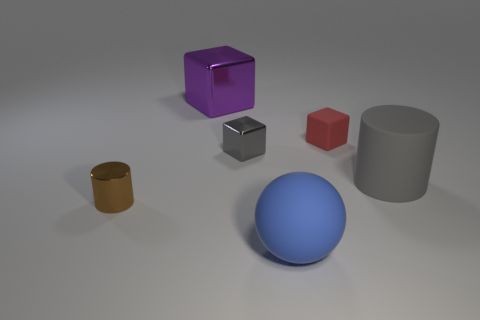Is the shape of the purple thing the same as the gray metal object?
Ensure brevity in your answer.  Yes. What is the shape of the small object that is the same color as the big matte cylinder?
Your answer should be very brief. Cube. What is the material of the object that is both behind the large gray cylinder and right of the tiny metallic cube?
Your answer should be compact. Rubber. The metallic object that is in front of the gray cylinder has what shape?
Your answer should be compact. Cylinder. There is a small object on the left side of the tiny metal object that is right of the big purple object; what shape is it?
Your response must be concise. Cylinder. Are there any blue things of the same shape as the brown thing?
Provide a short and direct response. No. The gray object that is the same size as the purple metallic block is what shape?
Provide a short and direct response. Cylinder. Are there any purple metallic things in front of the tiny thing that is right of the small metal object that is behind the large gray matte cylinder?
Your answer should be compact. No. Are there any red matte objects of the same size as the blue rubber object?
Ensure brevity in your answer.  No. What is the size of the metal cube that is in front of the tiny red matte thing?
Your answer should be very brief. Small. 